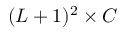Convert formula to latex. <formula><loc_0><loc_0><loc_500><loc_500>( L + 1 ) ^ { 2 } \times C</formula> 